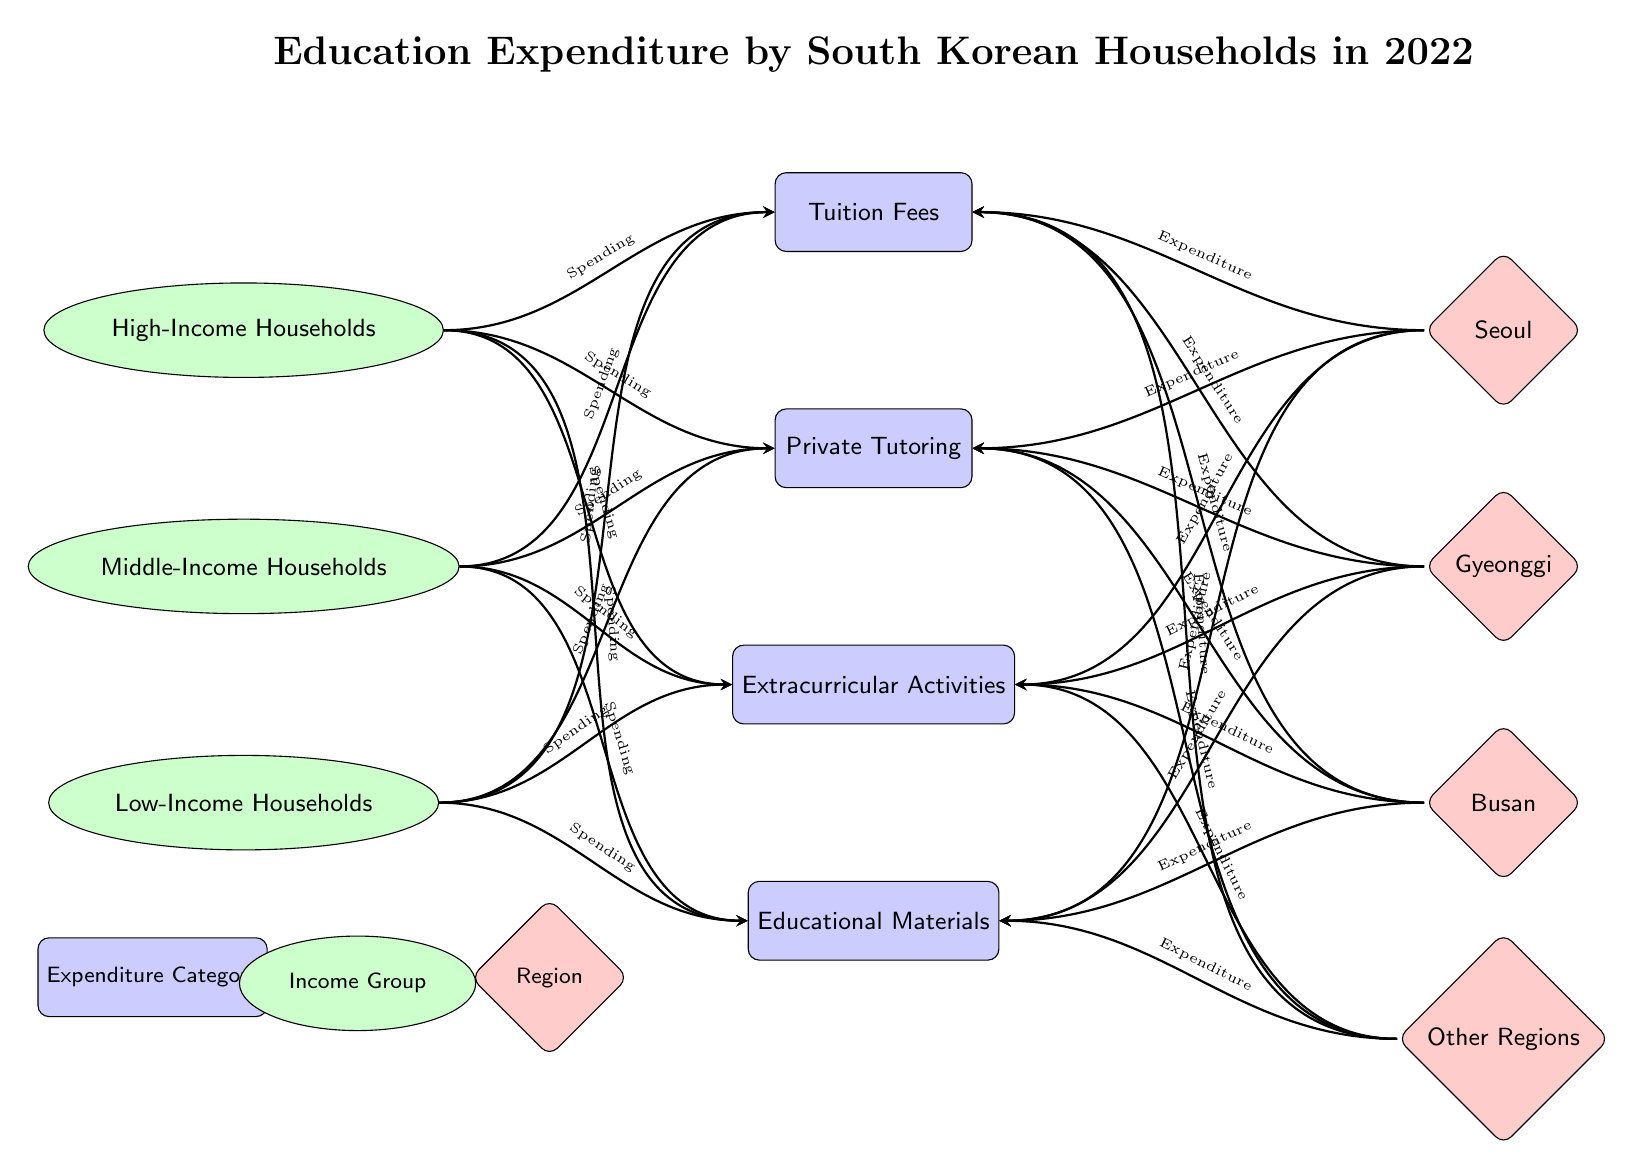What are the main expenditure categories shown in the diagram? The diagram lists four main expenditure categories: Tuition Fees, Private Tutoring, Extracurricular Activities, and Educational Materials.
Answer: Tuition Fees, Private Tutoring, Extracurricular Activities, Educational Materials Which income group is represented at the top of the diagram? In the diagram, the High-Income Households node is positioned at the top compared to Middle-Income and Low-Income Households.
Answer: High-Income Households How many geographic regions are indicated in the diagram? The diagram shows four regions: Seoul, Gyeonggi, Busan, and Other Regions. This can be counted visually.
Answer: 4 What type of arrows are used to connect income groups to expenditure categories? The arrows connecting income groups to the expenditure categories are labeled as "Spending," indicating the relationship. They are styled as directed arrows.
Answer: Spending Which region has a connection with the 'Private Tutoring' expenditure category? The arrows from the 'Seoul', 'Gyeonggi', 'Busan', and 'Other Regions' connect to 'Private Tutoring', indicating connections from these regions to this category.
Answer: Seoul, Gyeonggi, Busan, Other Regions Which income group likely spends the most on 'Extracurricular Activities'? Reasoning through the diagram's structure, High-Income Households would logically have more resources allocated to 'Extracurricular Activities' as indicated by their position and general trends in education spending.
Answer: High-Income Households How many arrows connect Low-Income Households to the expenditure categories? Each income group connects to all four expenditure categories, meaning there are four arrows connecting Low-Income Households to Tuition Fees, Private Tutoring, Extracurricular Activities, and Educational Materials.
Answer: 4 Which expenditure category seems to receive the least attention based on the diagram's arrangement? The positioning of 'Educational Materials' at the bottom suggests that it may receive comparatively less focus or spending attention compared to the other categories that are higher up.
Answer: Educational Materials In which region is private tutoring expenditure likely to be the highest? Considering urbanization and competitive education in South Korea, the diagram suggests that Seoul would likely have the highest expenditure on private tutoring.
Answer: Seoul 